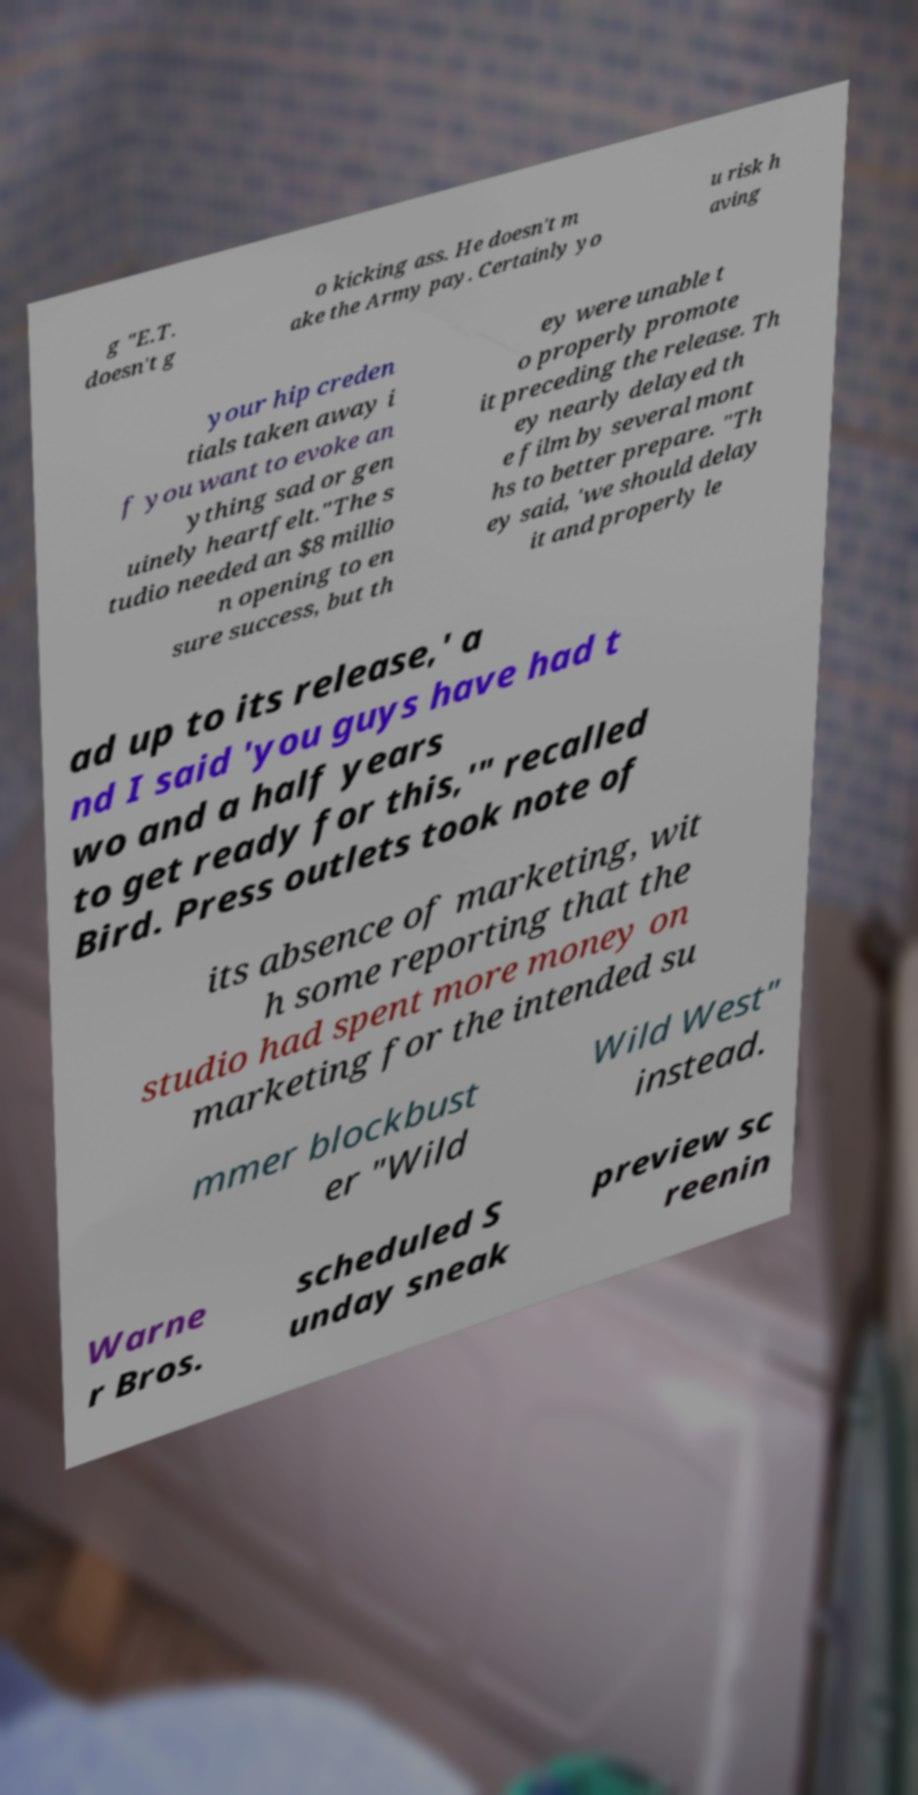I need the written content from this picture converted into text. Can you do that? g "E.T. doesn't g o kicking ass. He doesn't m ake the Army pay. Certainly yo u risk h aving your hip creden tials taken away i f you want to evoke an ything sad or gen uinely heartfelt."The s tudio needed an $8 millio n opening to en sure success, but th ey were unable t o properly promote it preceding the release. Th ey nearly delayed th e film by several mont hs to better prepare. "Th ey said, 'we should delay it and properly le ad up to its release,' a nd I said 'you guys have had t wo and a half years to get ready for this,'" recalled Bird. Press outlets took note of its absence of marketing, wit h some reporting that the studio had spent more money on marketing for the intended su mmer blockbust er "Wild Wild West" instead. Warne r Bros. scheduled S unday sneak preview sc reenin 